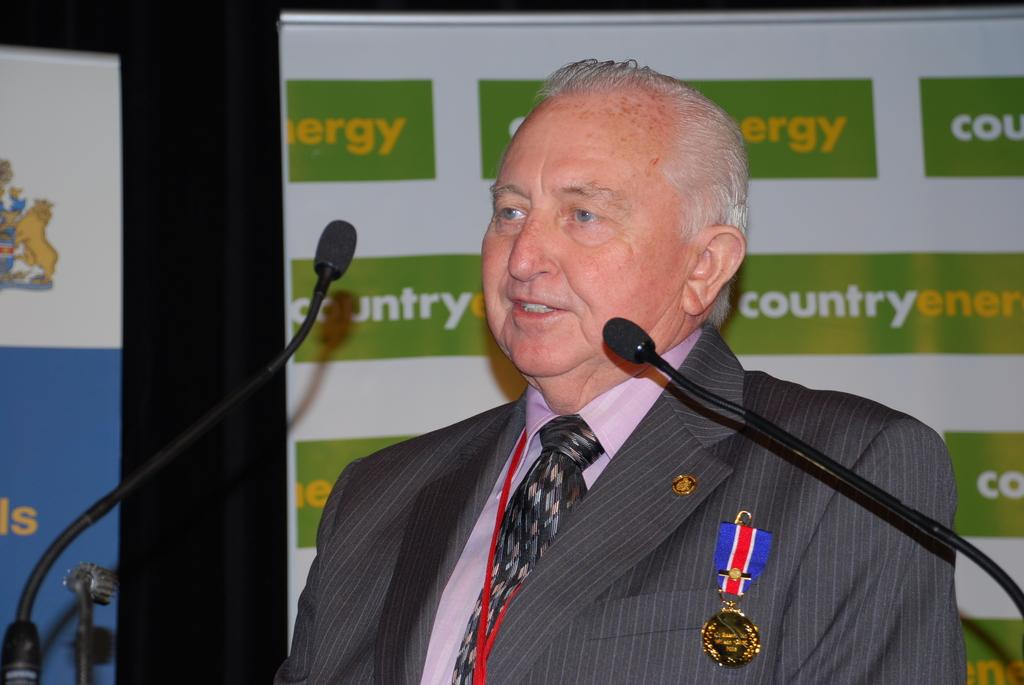Who is the main subject in the image? There is an old man in the image. What is the old man wearing? The old man is wearing a black suit. Where is the old man positioned in the image? The old man is standing in the front. What is the old man doing in the image? The old man is giving a speech. What is the old man holding in the image? There is a black microphone in the image. What can be seen in the background of the image? There is a green and white banner board in the background. What type of tools is the carpenter using in the image? There is no carpenter present in the image, nor are there any tools visible. What game is being played in the image? There is no game being played in the image; it features an old man giving a speech. 